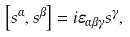<formula> <loc_0><loc_0><loc_500><loc_500>\left [ s ^ { \alpha } , s ^ { \beta } \right ] = i \varepsilon _ { \alpha \beta \gamma } s ^ { \gamma } ,</formula> 